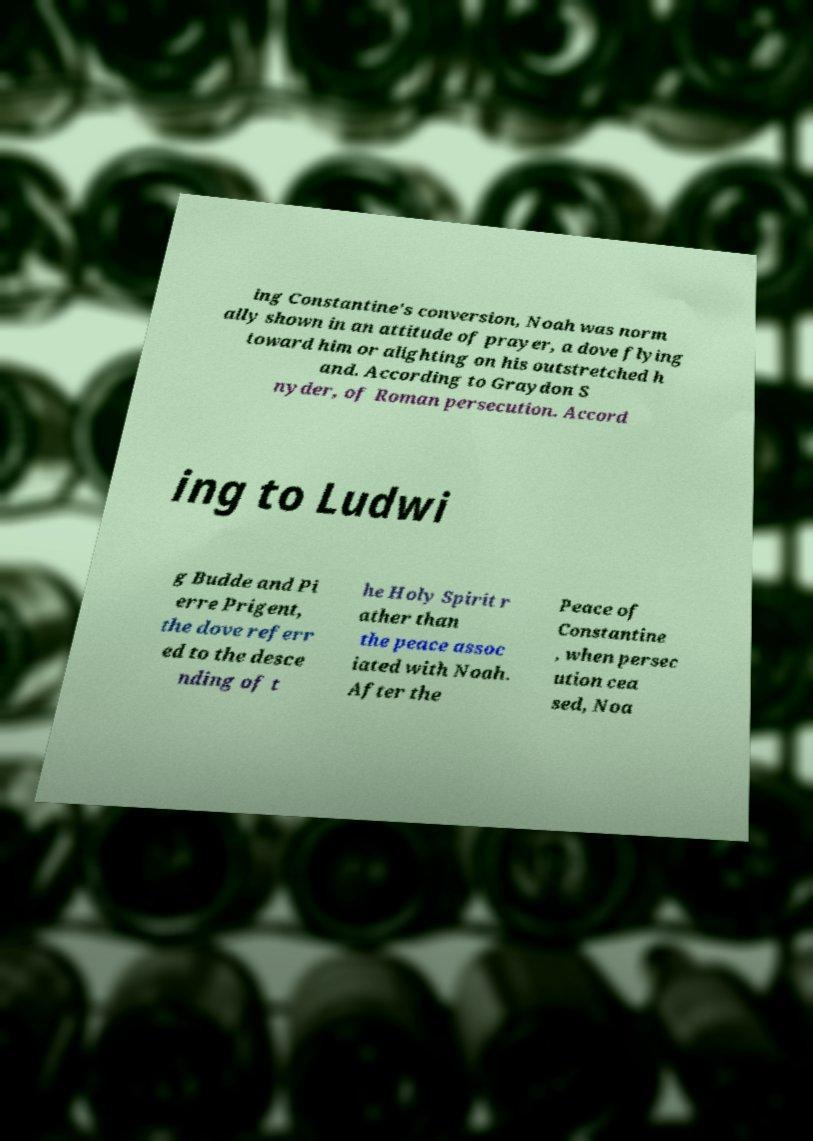I need the written content from this picture converted into text. Can you do that? ing Constantine's conversion, Noah was norm ally shown in an attitude of prayer, a dove flying toward him or alighting on his outstretched h and. According to Graydon S nyder, of Roman persecution. Accord ing to Ludwi g Budde and Pi erre Prigent, the dove referr ed to the desce nding of t he Holy Spirit r ather than the peace assoc iated with Noah. After the Peace of Constantine , when persec ution cea sed, Noa 